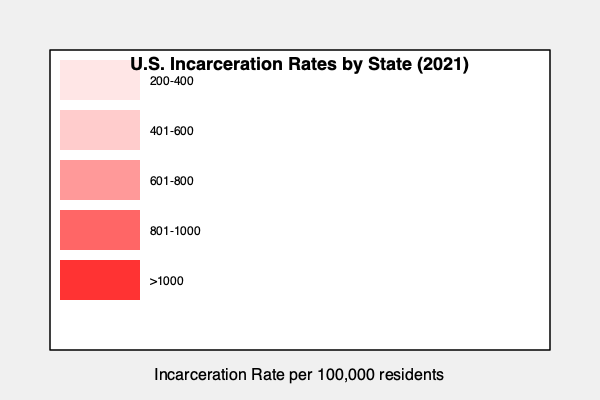Based on the choropleth map of U.S. incarceration rates by state in 2021, which region of the country appears to have the highest concentration of states with incarceration rates exceeding 800 per 100,000 residents? How might this relate to historical patterns of racial inequality? To answer this question, we need to analyze the choropleth map and consider historical context:

1. Observe the color gradient: Darker shades of red indicate higher incarceration rates.

2. Identify regions with the darkest colors: The southeastern United States shows the highest concentration of dark red states, indicating incarceration rates above 800 per 100,000 residents.

3. Historical context:
   a) The Southeast has a history of slavery and Jim Crow laws.
   b) This region was at the center of the Civil Rights Movement due to entrenched racial segregation and discrimination.
   c) The "War on Drugs" disproportionately affected Black communities in this region.

4. Racial inequality connection:
   a) Higher incarceration rates in the Southeast correlate with areas of historical racial oppression.
   b) Systemic racism in policing, sentencing, and socioeconomic factors contribute to higher incarceration rates for people of color.
   c) The legacy of racist policies and practices continues to impact incarceration rates today.

5. Critical analysis:
   a) Consider how these high incarceration rates perpetuate cycles of poverty and disenfranchisement in communities of color.
   b) Reflect on how this data demonstrates the ongoing impact of historical racial inequalities in the criminal justice system.
Answer: The Southeast, reflecting the lasting impact of historical racial oppression and systemic inequalities in the criminal justice system. 